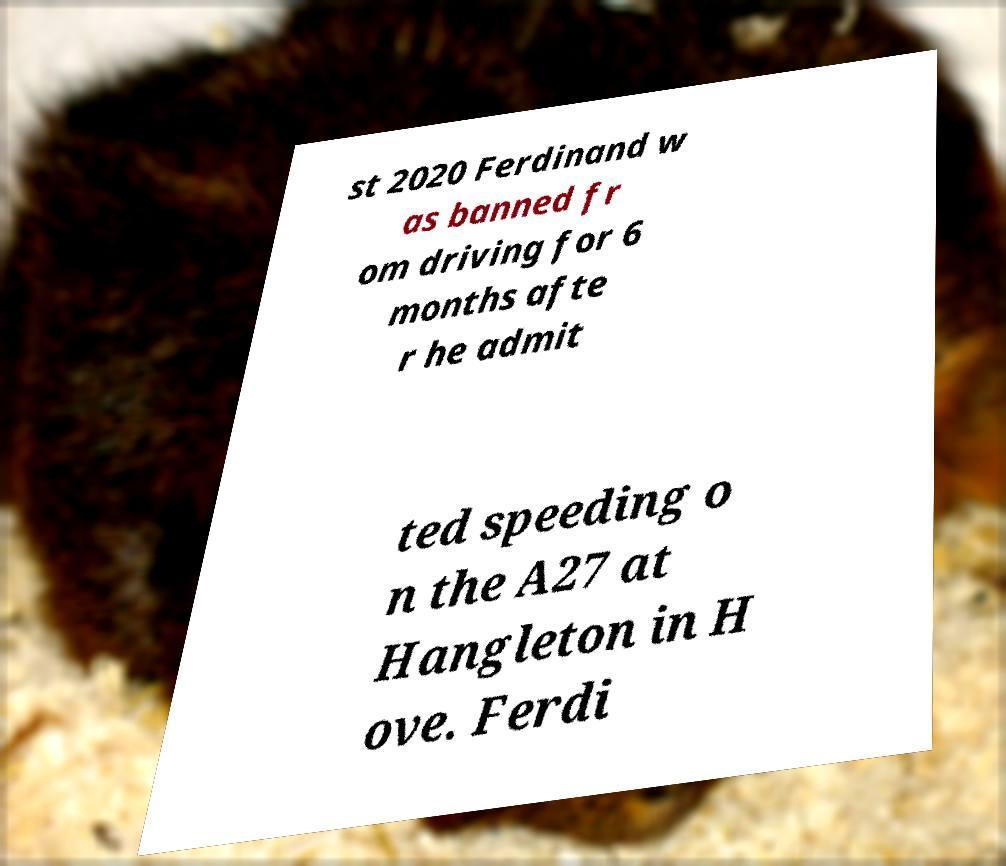Could you assist in decoding the text presented in this image and type it out clearly? st 2020 Ferdinand w as banned fr om driving for 6 months afte r he admit ted speeding o n the A27 at Hangleton in H ove. Ferdi 